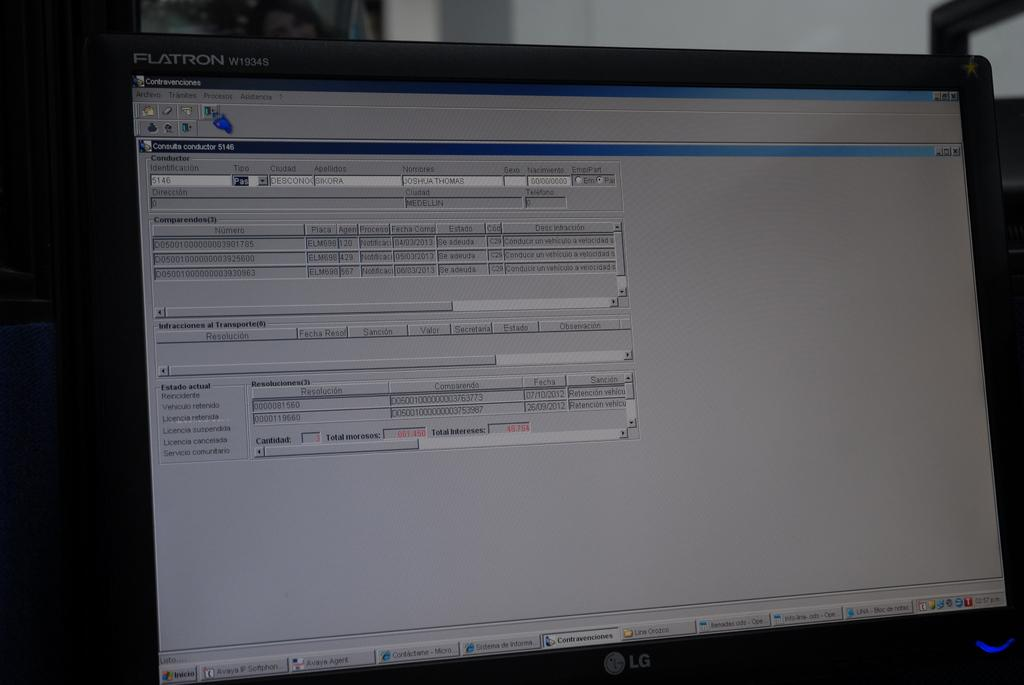<image>
Relay a brief, clear account of the picture shown. A Flatron open laptop screen showing a document. 